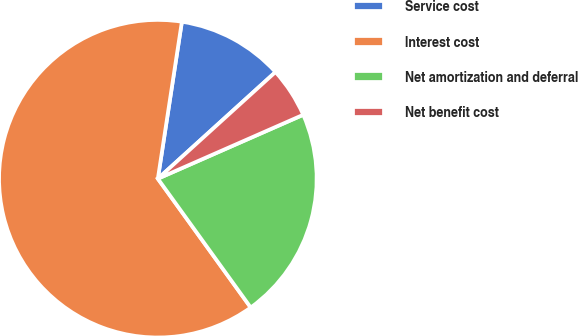Convert chart to OTSL. <chart><loc_0><loc_0><loc_500><loc_500><pie_chart><fcel>Service cost<fcel>Interest cost<fcel>Net amortization and deferral<fcel>Net benefit cost<nl><fcel>10.86%<fcel>62.36%<fcel>21.65%<fcel>5.13%<nl></chart> 